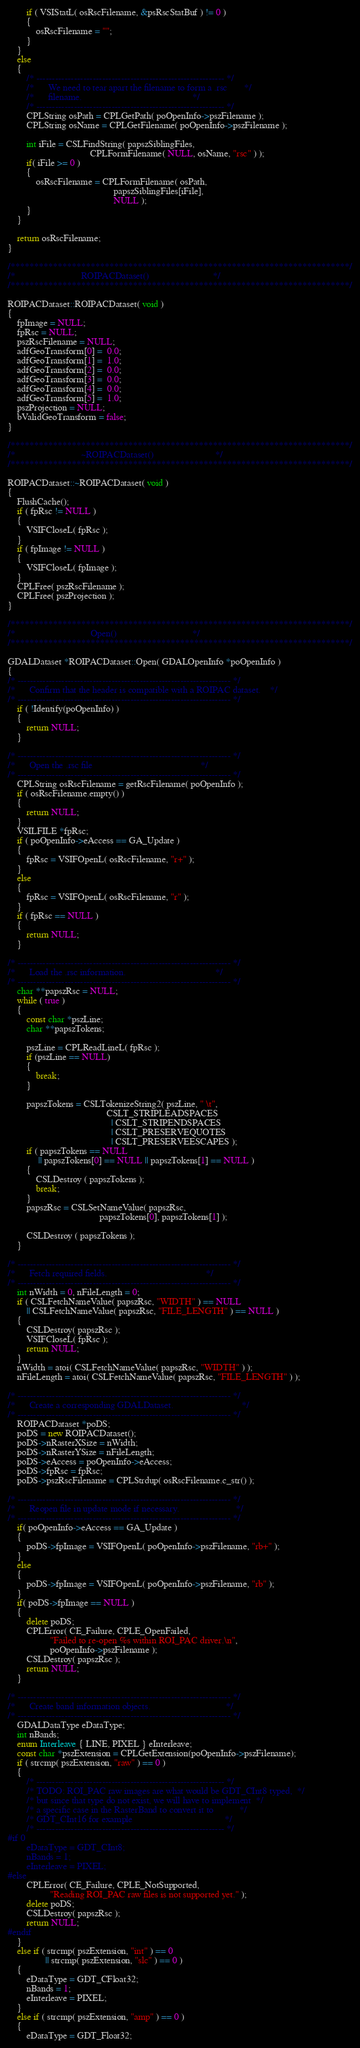Convert code to text. <code><loc_0><loc_0><loc_500><loc_500><_C++_>        if ( VSIStatL( osRscFilename, &psRscStatBuf ) != 0 ) 
        {
            osRscFilename = "";
        }
    }
    else
    {
        /* ------------------------------------------------------------ */
        /*      We need to tear apart the filename to form a .rsc       */
        /*      filename.                                               */
        /* ------------------------------------------------------------ */
        CPLString osPath = CPLGetPath( poOpenInfo->pszFilename );
        CPLString osName = CPLGetFilename( poOpenInfo->pszFilename );

        int iFile = CSLFindString( papszSiblingFiles,
                                   CPLFormFilename( NULL, osName, "rsc" ) );
        if( iFile >= 0 )
        {
            osRscFilename = CPLFormFilename( osPath,
                                             papszSiblingFiles[iFile],
                                             NULL );
        }
    }

    return osRscFilename;
}

/************************************************************************/
/*                            ROIPACDataset()                           */
/************************************************************************/

ROIPACDataset::ROIPACDataset( void )
{
    fpImage = NULL;
    fpRsc = NULL;
    pszRscFilename = NULL;
    adfGeoTransform[0] =  0.0;
    adfGeoTransform[1] =  1.0;
    adfGeoTransform[2] =  0.0;
    adfGeoTransform[3] =  0.0;
    adfGeoTransform[4] =  0.0;
    adfGeoTransform[5] =  1.0;
    pszProjection = NULL;
    bValidGeoTransform = false;
}

/************************************************************************/
/*                            ~ROIPACDataset()                          */
/************************************************************************/

ROIPACDataset::~ROIPACDataset( void )
{
    FlushCache();
    if ( fpRsc != NULL )
    {
        VSIFCloseL( fpRsc );
    }
    if ( fpImage != NULL )
    {
        VSIFCloseL( fpImage );
    }
    CPLFree( pszRscFilename );
    CPLFree( pszProjection );
}

/************************************************************************/
/*                                Open()                                */
/************************************************************************/

GDALDataset *ROIPACDataset::Open( GDALOpenInfo *poOpenInfo )
{
/* -------------------------------------------------------------------- */
/*      Confirm that the header is compatible with a ROIPAC dataset.    */
/* -------------------------------------------------------------------- */
    if ( !Identify(poOpenInfo) )
    {
        return NULL;
    }

/* -------------------------------------------------------------------- */
/*      Open the .rsc file                                              */
/* -------------------------------------------------------------------- */
    CPLString osRscFilename = getRscFilename( poOpenInfo );
    if ( osRscFilename.empty() )
    {
        return NULL;
    }
    VSILFILE *fpRsc;
    if ( poOpenInfo->eAccess == GA_Update )
    {
        fpRsc = VSIFOpenL( osRscFilename, "r+" );
    }
    else
    {
        fpRsc = VSIFOpenL( osRscFilename, "r" );
    }
    if ( fpRsc == NULL )
    {
        return NULL;
    }

/* -------------------------------------------------------------------- */
/*      Load the .rsc information.                                      */
/* -------------------------------------------------------------------- */
    char **papszRsc = NULL;
    while ( true )
    {
        const char *pszLine;
        char **papszTokens;

        pszLine = CPLReadLineL( fpRsc );
        if (pszLine == NULL)
        {
            break;
        }

        papszTokens = CSLTokenizeString2( pszLine, " \t",
                                          CSLT_STRIPLEADSPACES
                                            | CSLT_STRIPENDSPACES
                                            | CSLT_PRESERVEQUOTES
                                            | CSLT_PRESERVEESCAPES );
        if ( papszTokens == NULL 
             || papszTokens[0] == NULL || papszTokens[1] == NULL )
        {
            CSLDestroy ( papszTokens );
            break;
        }
        papszRsc = CSLSetNameValue( papszRsc,
                                       papszTokens[0], papszTokens[1] );

        CSLDestroy ( papszTokens );
    }

/* -------------------------------------------------------------------- */
/*      Fetch required fields.                                          */
/* -------------------------------------------------------------------- */
    int nWidth = 0, nFileLength = 0;
    if ( CSLFetchNameValue( papszRsc, "WIDTH" ) == NULL
        || CSLFetchNameValue( papszRsc, "FILE_LENGTH" ) == NULL )
    {
        CSLDestroy( papszRsc );
        VSIFCloseL( fpRsc );
        return NULL;
    }
    nWidth = atoi( CSLFetchNameValue( papszRsc, "WIDTH" ) ); 
    nFileLength = atoi( CSLFetchNameValue( papszRsc, "FILE_LENGTH" ) );

/* -------------------------------------------------------------------- */
/*      Create a corresponding GDALDataset.                             */
/* -------------------------------------------------------------------- */
    ROIPACDataset *poDS;
    poDS = new ROIPACDataset();
    poDS->nRasterXSize = nWidth;
    poDS->nRasterYSize = nFileLength;
    poDS->eAccess = poOpenInfo->eAccess;
    poDS->fpRsc = fpRsc;
    poDS->pszRscFilename = CPLStrdup( osRscFilename.c_str() );

/* -------------------------------------------------------------------- */
/*      Reopen file in update mode if necessary.                        */
/* -------------------------------------------------------------------- */
    if( poOpenInfo->eAccess == GA_Update )
    {
        poDS->fpImage = VSIFOpenL( poOpenInfo->pszFilename, "rb+" );
    }
    else
    {
        poDS->fpImage = VSIFOpenL( poOpenInfo->pszFilename, "rb" );
    }
    if( poDS->fpImage == NULL )
    {
        delete poDS;
        CPLError( CE_Failure, CPLE_OpenFailed,
                  "Failed to re-open %s within ROI_PAC driver.\n",
                  poOpenInfo->pszFilename );
        CSLDestroy( papszRsc );
        return NULL;
    }

/* -------------------------------------------------------------------- */
/*      Create band information objects.                                */
/* -------------------------------------------------------------------- */
    GDALDataType eDataType;
    int nBands;
    enum Interleave { LINE, PIXEL } eInterleave;
    const char *pszExtension = CPLGetExtension(poOpenInfo->pszFilename);
    if ( strcmp( pszExtension, "raw" ) == 0 )
    {
        /* ------------------------------------------------------------ */
        /* TODO: ROI_PAC raw images are what would be GDT_CInt8 typed,  */
        /* but since that type do not exist, we will have to implement  */
        /* a specific case in the RasterBand to convert it to           */
        /* GDT_CInt16 for example                                       */
        /* ------------------------------------------------------------ */
#if 0
        eDataType = GDT_CInt8;
        nBands = 1;
        eInterleave = PIXEL;
#else
        CPLError( CE_Failure, CPLE_NotSupported,
                  "Reading ROI_PAC raw files is not supported yet." );
        delete poDS;
        CSLDestroy( papszRsc );
        return NULL;
#endif
    }
    else if ( strcmp( pszExtension, "int" ) == 0
                || strcmp( pszExtension, "slc" ) == 0 )
    {
        eDataType = GDT_CFloat32;
        nBands = 1;
        eInterleave = PIXEL;
    }
    else if ( strcmp( pszExtension, "amp" ) == 0 )
    {
        eDataType = GDT_Float32;</code> 